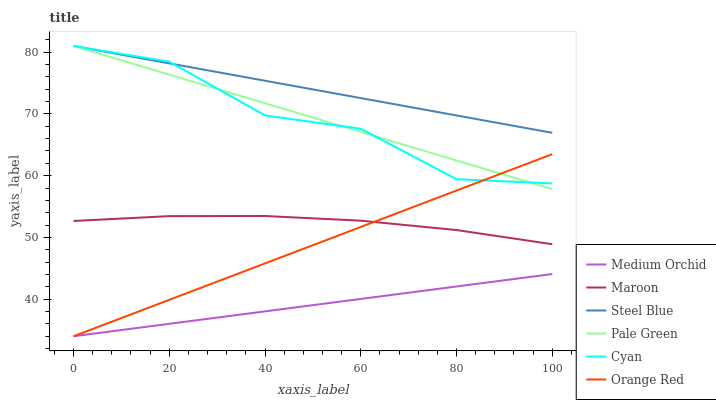Does Medium Orchid have the minimum area under the curve?
Answer yes or no. Yes. Does Steel Blue have the maximum area under the curve?
Answer yes or no. Yes. Does Maroon have the minimum area under the curve?
Answer yes or no. No. Does Maroon have the maximum area under the curve?
Answer yes or no. No. Is Medium Orchid the smoothest?
Answer yes or no. Yes. Is Cyan the roughest?
Answer yes or no. Yes. Is Steel Blue the smoothest?
Answer yes or no. No. Is Steel Blue the roughest?
Answer yes or no. No. Does Medium Orchid have the lowest value?
Answer yes or no. Yes. Does Maroon have the lowest value?
Answer yes or no. No. Does Cyan have the highest value?
Answer yes or no. Yes. Does Maroon have the highest value?
Answer yes or no. No. Is Medium Orchid less than Cyan?
Answer yes or no. Yes. Is Maroon greater than Medium Orchid?
Answer yes or no. Yes. Does Steel Blue intersect Pale Green?
Answer yes or no. Yes. Is Steel Blue less than Pale Green?
Answer yes or no. No. Is Steel Blue greater than Pale Green?
Answer yes or no. No. Does Medium Orchid intersect Cyan?
Answer yes or no. No. 